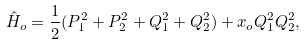<formula> <loc_0><loc_0><loc_500><loc_500>\hat { H } _ { o } = \frac { 1 } { 2 } ( P ^ { 2 } _ { 1 } + P ^ { 2 } _ { 2 } + Q ^ { 2 } _ { 1 } + Q ^ { 2 } _ { 2 } ) + x _ { o } Q ^ { 2 } _ { 1 } Q ^ { 2 } _ { 2 } ,</formula> 